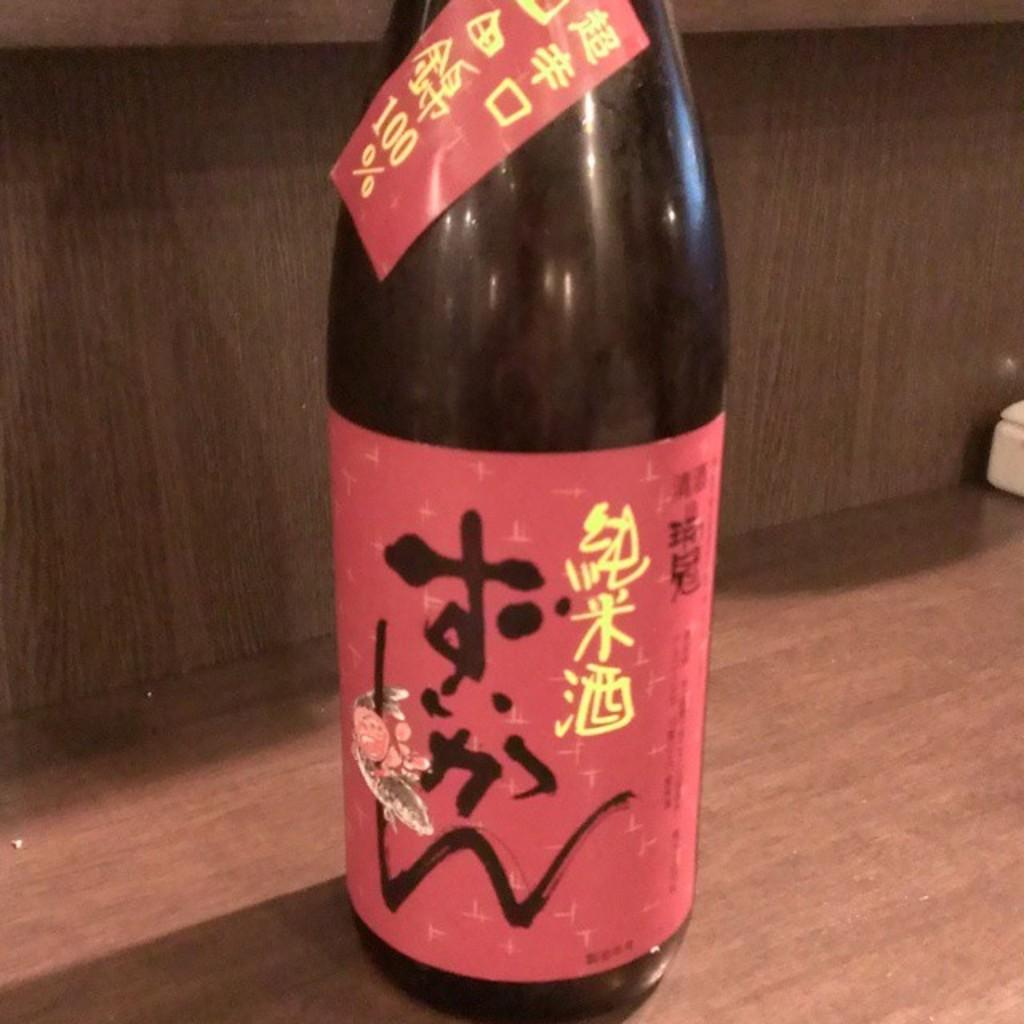<image>
Offer a succinct explanation of the picture presented. Bottle with a sticker on it that says 100% on top of a table. 